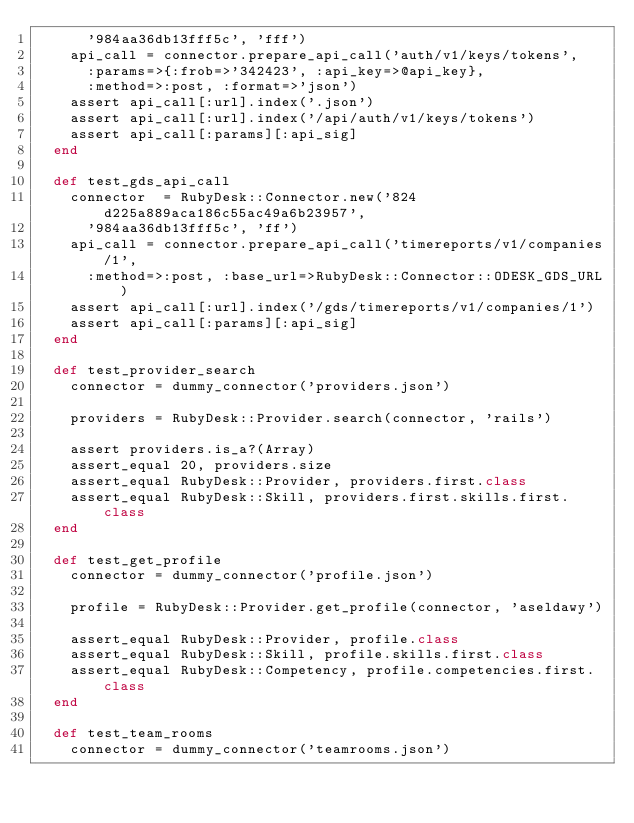Convert code to text. <code><loc_0><loc_0><loc_500><loc_500><_Ruby_>      '984aa36db13fff5c', 'fff')
    api_call = connector.prepare_api_call('auth/v1/keys/tokens',
      :params=>{:frob=>'342423', :api_key=>@api_key},
      :method=>:post, :format=>'json')
    assert api_call[:url].index('.json')
    assert api_call[:url].index('/api/auth/v1/keys/tokens')
    assert api_call[:params][:api_sig]
  end

  def test_gds_api_call
    connector  = RubyDesk::Connector.new('824d225a889aca186c55ac49a6b23957',
      '984aa36db13fff5c', 'ff')
    api_call = connector.prepare_api_call('timereports/v1/companies/1',
      :method=>:post, :base_url=>RubyDesk::Connector::ODESK_GDS_URL)
    assert api_call[:url].index('/gds/timereports/v1/companies/1')
    assert api_call[:params][:api_sig]
  end

  def test_provider_search
    connector = dummy_connector('providers.json')

    providers = RubyDesk::Provider.search(connector, 'rails')

    assert providers.is_a?(Array)
    assert_equal 20, providers.size
    assert_equal RubyDesk::Provider, providers.first.class
    assert_equal RubyDesk::Skill, providers.first.skills.first.class
  end

  def test_get_profile
    connector = dummy_connector('profile.json')

    profile = RubyDesk::Provider.get_profile(connector, 'aseldawy')

    assert_equal RubyDesk::Provider, profile.class
    assert_equal RubyDesk::Skill, profile.skills.first.class
    assert_equal RubyDesk::Competency, profile.competencies.first.class
  end

  def test_team_rooms
    connector = dummy_connector('teamrooms.json')
</code> 